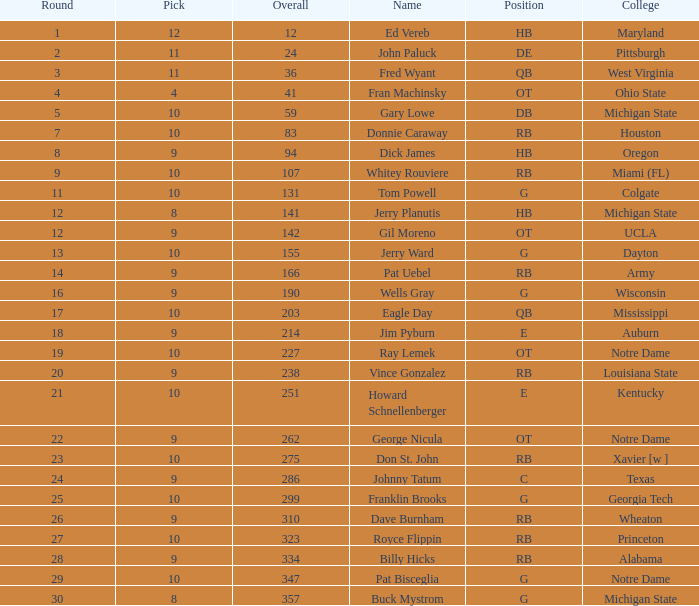What is the greatest overall pick figure for george nicula who had a pick below 9? None. 